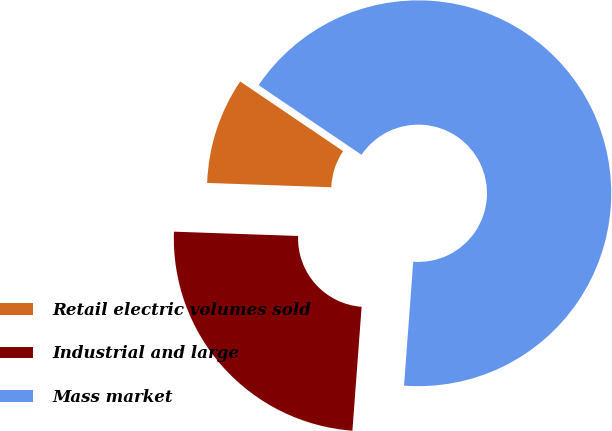Convert chart. <chart><loc_0><loc_0><loc_500><loc_500><pie_chart><fcel>Retail electric volumes sold<fcel>Industrial and large<fcel>Mass market<nl><fcel>8.92%<fcel>24.37%<fcel>66.71%<nl></chart> 